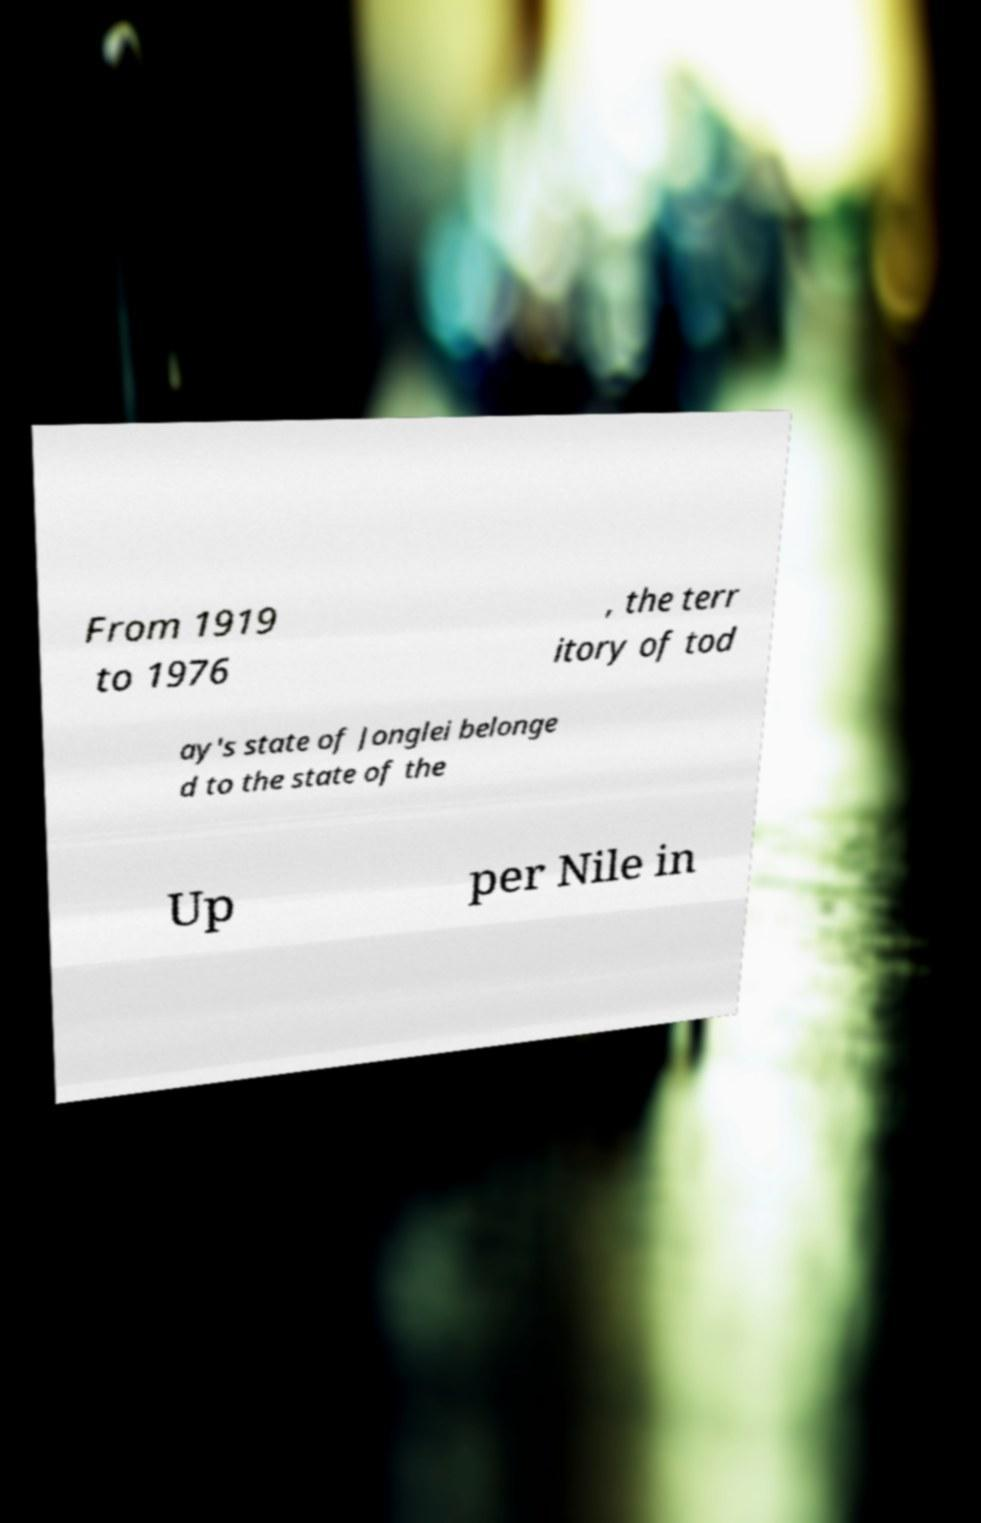Please read and relay the text visible in this image. What does it say? From 1919 to 1976 , the terr itory of tod ay's state of Jonglei belonge d to the state of the Up per Nile in 